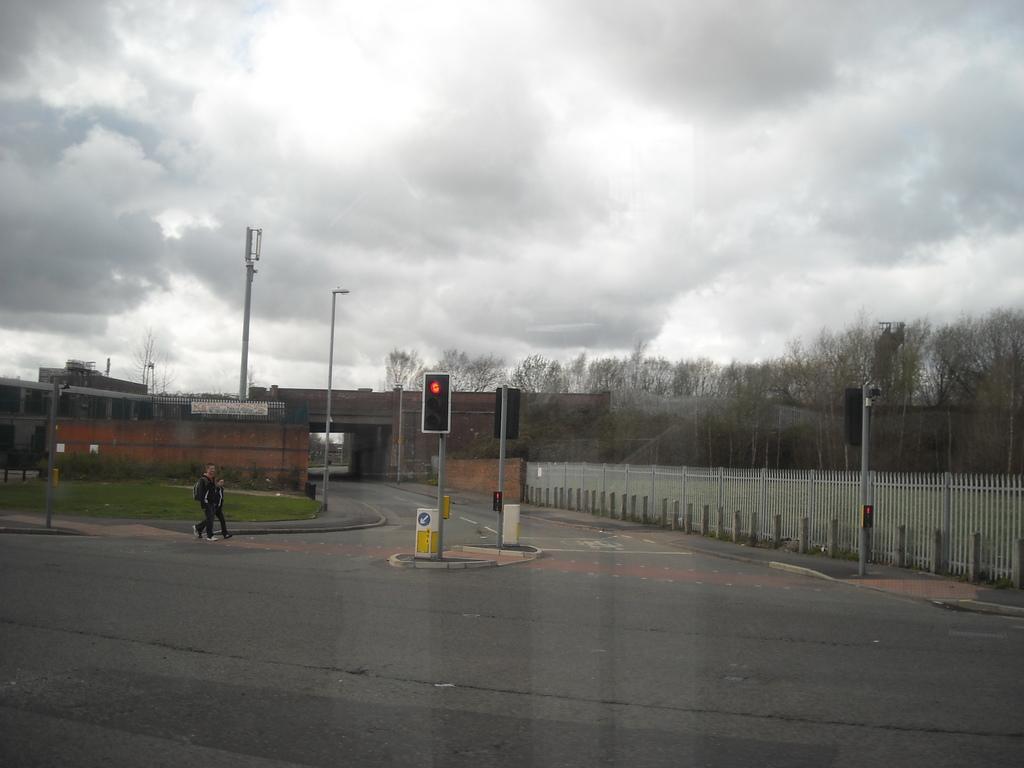Please provide a concise description of this image. In this image there is a road, two persons are crossing the road on that road there are signal poles, on the right side there is fencing, in the background there is a tunnel, trees and a cloudy sky. 